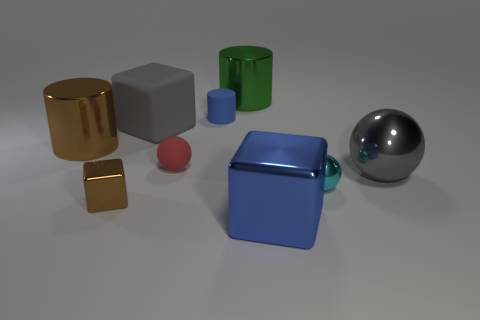Subtract all purple cylinders. Subtract all blue blocks. How many cylinders are left? 3 Subtract all balls. How many objects are left? 6 Add 9 large rubber spheres. How many large rubber spheres exist? 9 Subtract 0 purple spheres. How many objects are left? 9 Subtract all large green cylinders. Subtract all large spheres. How many objects are left? 7 Add 1 big green objects. How many big green objects are left? 2 